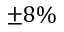<formula> <loc_0><loc_0><loc_500><loc_500>\pm 8 \%</formula> 